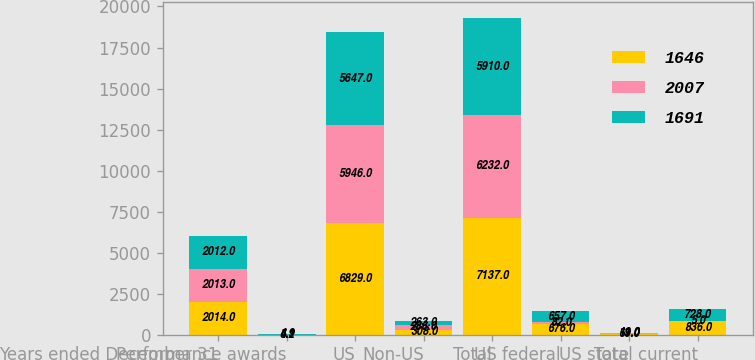Convert chart to OTSL. <chart><loc_0><loc_0><loc_500><loc_500><stacked_bar_chart><ecel><fcel>Years ended December 31<fcel>Performance awards<fcel>US<fcel>Non-US<fcel>Total<fcel>US federal<fcel>US state<fcel>Total current<nl><fcel>1646<fcel>2014<fcel>5.1<fcel>6829<fcel>308<fcel>7137<fcel>676<fcel>69<fcel>836<nl><fcel>2007<fcel>2013<fcel>4.2<fcel>5946<fcel>286<fcel>6232<fcel>82<fcel>11<fcel>5<nl><fcel>1691<fcel>2012<fcel>4.9<fcel>5647<fcel>263<fcel>5910<fcel>657<fcel>19<fcel>728<nl></chart> 